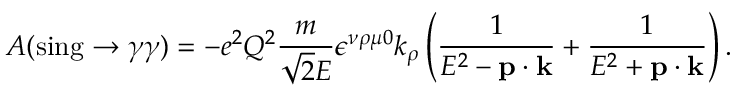<formula> <loc_0><loc_0><loc_500><loc_500>A ( \sin g \rightarrow \gamma \gamma ) = - e ^ { 2 } Q ^ { 2 } { \frac { m } { \sqrt { 2 } E } } \epsilon ^ { \nu \rho \mu 0 } k _ { \rho } \left ( { \frac { 1 } { E ^ { 2 } - { p } \cdot { k } } } + { \frac { 1 } { E ^ { 2 } + { p } \cdot { k } } } \right ) .</formula> 